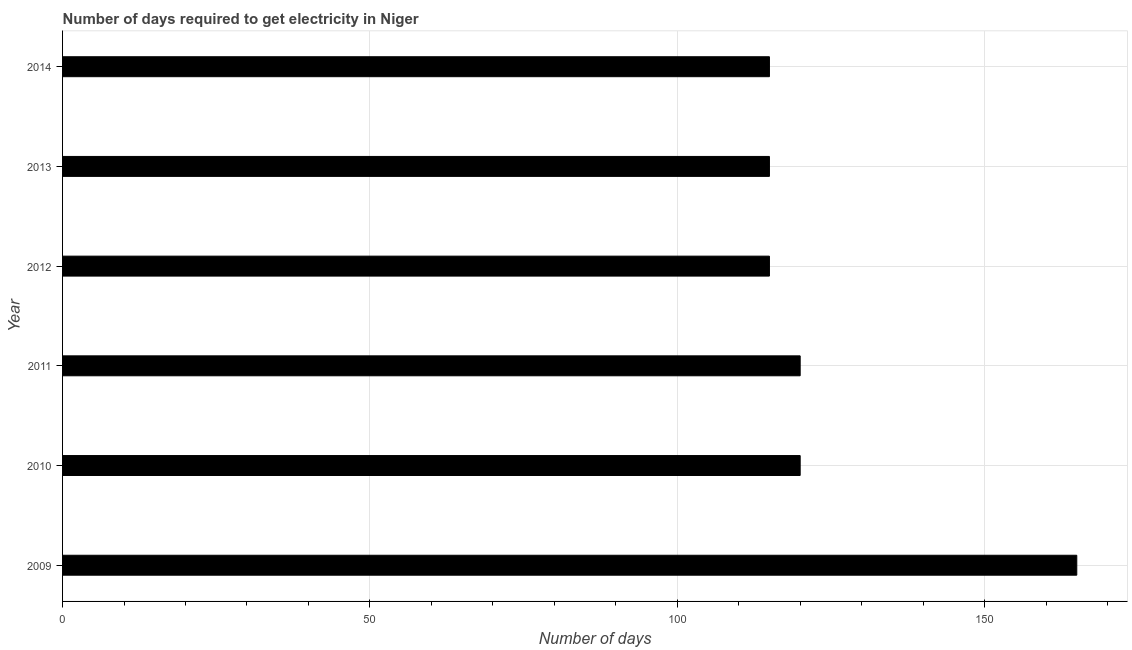Does the graph contain grids?
Offer a terse response. Yes. What is the title of the graph?
Your answer should be very brief. Number of days required to get electricity in Niger. What is the label or title of the X-axis?
Keep it short and to the point. Number of days. What is the time to get electricity in 2012?
Offer a terse response. 115. Across all years, what is the maximum time to get electricity?
Your answer should be very brief. 165. Across all years, what is the minimum time to get electricity?
Provide a short and direct response. 115. In which year was the time to get electricity maximum?
Provide a short and direct response. 2009. What is the sum of the time to get electricity?
Give a very brief answer. 750. What is the average time to get electricity per year?
Provide a short and direct response. 125. What is the median time to get electricity?
Your answer should be very brief. 117.5. Do a majority of the years between 2014 and 2011 (inclusive) have time to get electricity greater than 50 ?
Your answer should be very brief. Yes. What is the ratio of the time to get electricity in 2010 to that in 2013?
Offer a terse response. 1.04. What is the difference between the highest and the second highest time to get electricity?
Your answer should be compact. 45. Is the sum of the time to get electricity in 2009 and 2014 greater than the maximum time to get electricity across all years?
Keep it short and to the point. Yes. What is the difference between the highest and the lowest time to get electricity?
Your answer should be very brief. 50. In how many years, is the time to get electricity greater than the average time to get electricity taken over all years?
Your response must be concise. 1. Are all the bars in the graph horizontal?
Provide a short and direct response. Yes. How many years are there in the graph?
Ensure brevity in your answer.  6. What is the Number of days of 2009?
Your answer should be very brief. 165. What is the Number of days in 2010?
Provide a succinct answer. 120. What is the Number of days in 2011?
Your response must be concise. 120. What is the Number of days of 2012?
Keep it short and to the point. 115. What is the Number of days of 2013?
Your answer should be compact. 115. What is the Number of days of 2014?
Offer a terse response. 115. What is the difference between the Number of days in 2009 and 2012?
Make the answer very short. 50. What is the difference between the Number of days in 2009 and 2014?
Keep it short and to the point. 50. What is the difference between the Number of days in 2010 and 2011?
Offer a terse response. 0. What is the difference between the Number of days in 2011 and 2014?
Make the answer very short. 5. What is the difference between the Number of days in 2012 and 2013?
Keep it short and to the point. 0. What is the difference between the Number of days in 2012 and 2014?
Keep it short and to the point. 0. What is the difference between the Number of days in 2013 and 2014?
Make the answer very short. 0. What is the ratio of the Number of days in 2009 to that in 2010?
Provide a succinct answer. 1.38. What is the ratio of the Number of days in 2009 to that in 2011?
Your answer should be compact. 1.38. What is the ratio of the Number of days in 2009 to that in 2012?
Give a very brief answer. 1.44. What is the ratio of the Number of days in 2009 to that in 2013?
Offer a terse response. 1.44. What is the ratio of the Number of days in 2009 to that in 2014?
Offer a very short reply. 1.44. What is the ratio of the Number of days in 2010 to that in 2011?
Offer a terse response. 1. What is the ratio of the Number of days in 2010 to that in 2012?
Keep it short and to the point. 1.04. What is the ratio of the Number of days in 2010 to that in 2013?
Offer a terse response. 1.04. What is the ratio of the Number of days in 2010 to that in 2014?
Provide a succinct answer. 1.04. What is the ratio of the Number of days in 2011 to that in 2012?
Offer a very short reply. 1.04. What is the ratio of the Number of days in 2011 to that in 2013?
Your answer should be compact. 1.04. What is the ratio of the Number of days in 2011 to that in 2014?
Your response must be concise. 1.04. What is the ratio of the Number of days in 2012 to that in 2013?
Your response must be concise. 1. What is the ratio of the Number of days in 2012 to that in 2014?
Keep it short and to the point. 1. 